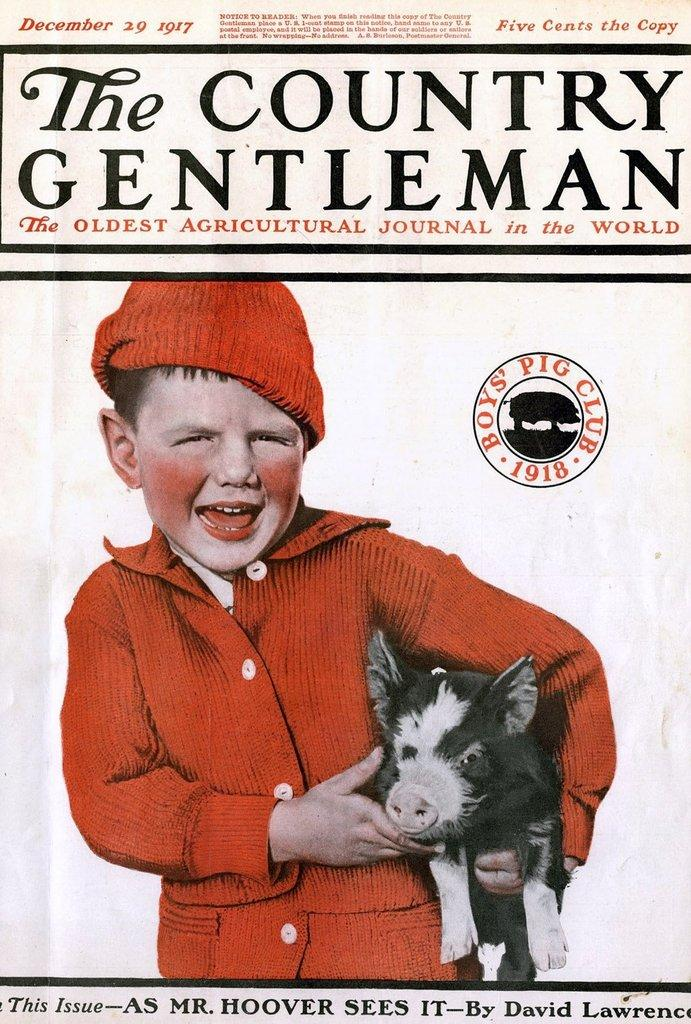What is the main subject in the center of the image? There is a poster in the center of the image. What words are written on the poster? The words "the country gentleman" are written on the poster. How many ducks are visible in the image? There are no ducks present in the image. What type of minister is depicted in the image? There is no minister depicted in the image; it features a poster with the words "the country gentleman." 